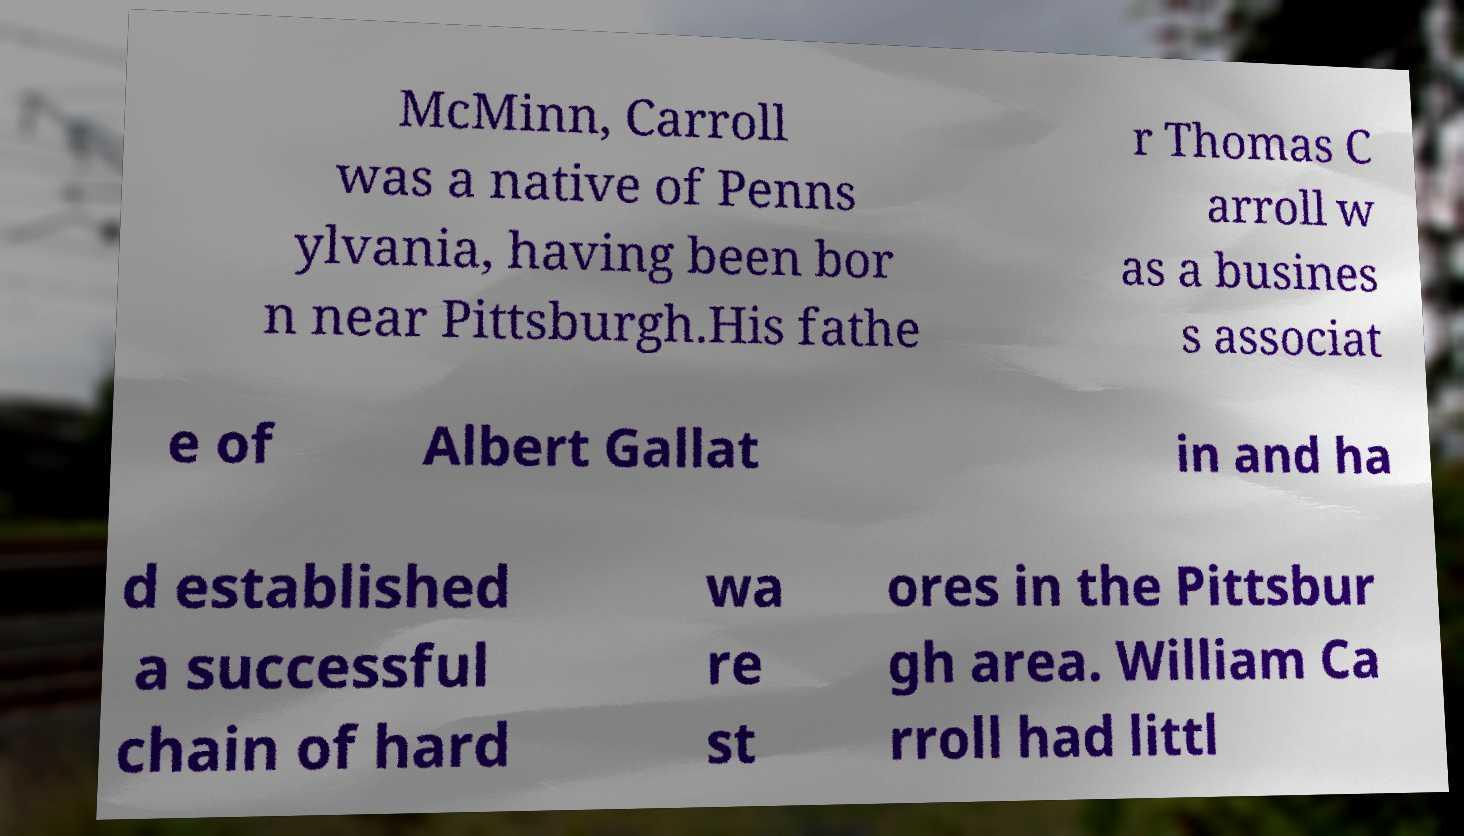Please identify and transcribe the text found in this image. McMinn, Carroll was a native of Penns ylvania, having been bor n near Pittsburgh.His fathe r Thomas C arroll w as a busines s associat e of Albert Gallat in and ha d established a successful chain of hard wa re st ores in the Pittsbur gh area. William Ca rroll had littl 